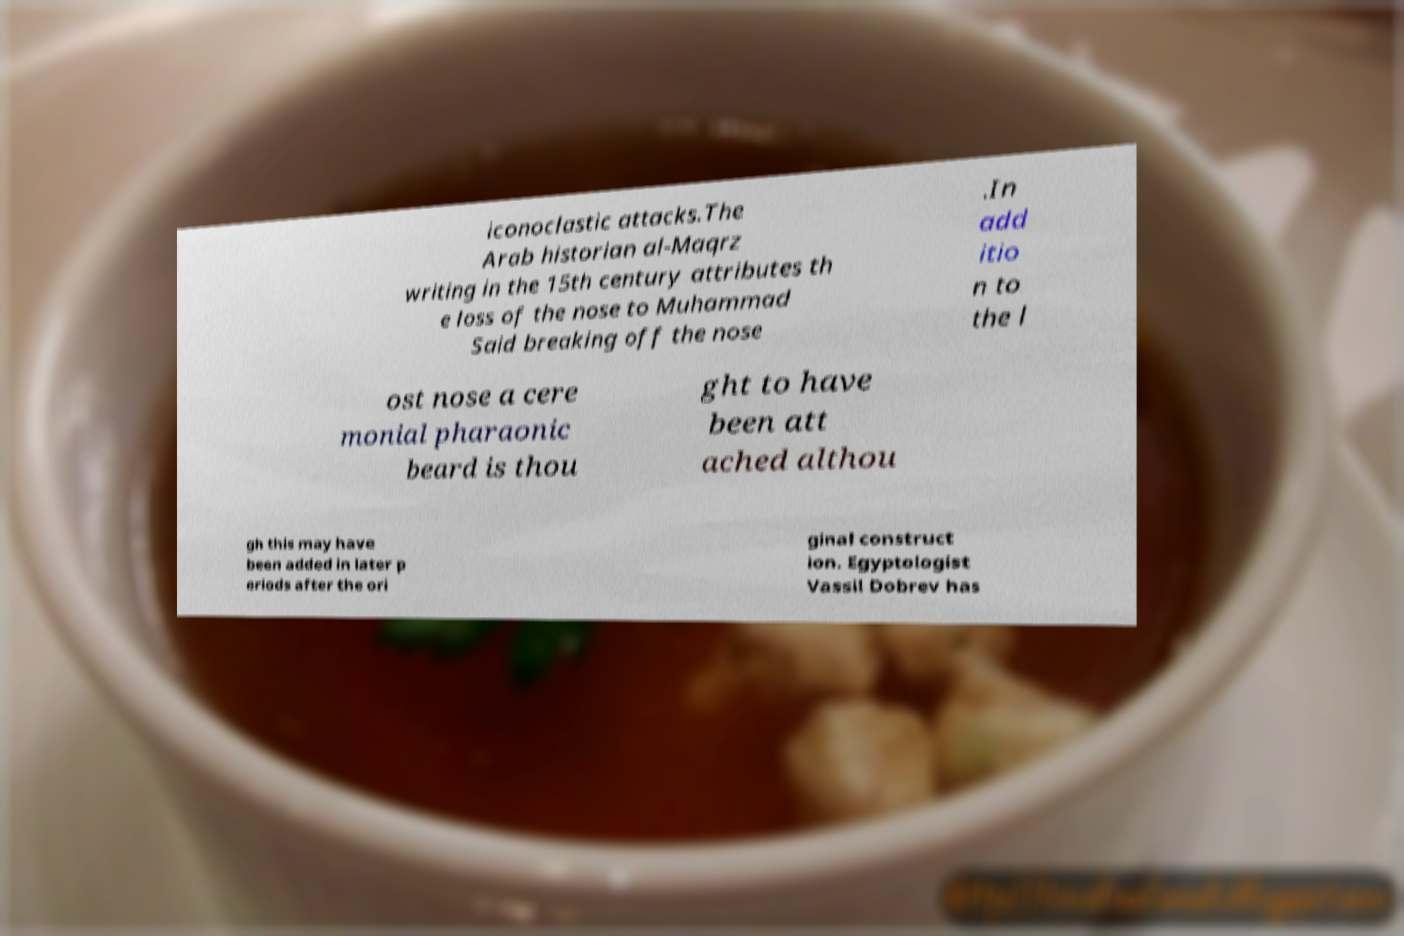For documentation purposes, I need the text within this image transcribed. Could you provide that? iconoclastic attacks.The Arab historian al-Maqrz writing in the 15th century attributes th e loss of the nose to Muhammad Said breaking off the nose .In add itio n to the l ost nose a cere monial pharaonic beard is thou ght to have been att ached althou gh this may have been added in later p eriods after the ori ginal construct ion. Egyptologist Vassil Dobrev has 